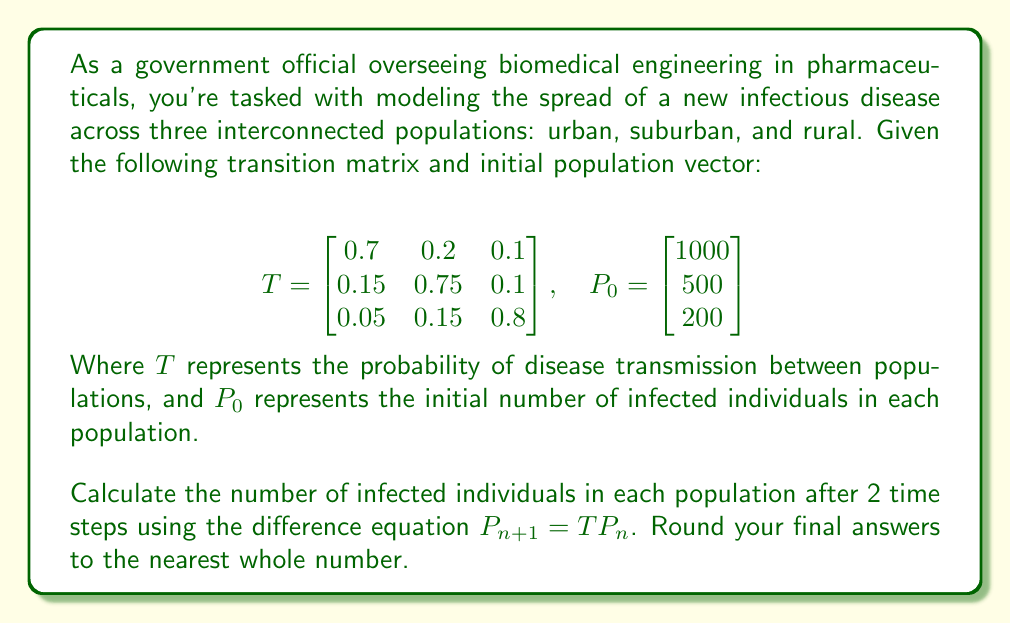Show me your answer to this math problem. To solve this problem, we'll use matrix multiplication and apply the difference equation twice.

Step 1: Calculate $P_1$ (infected population after 1 time step)
$$P_1 = TP_0 = \begin{bmatrix}
0.7 & 0.2 & 0.1 \\
0.15 & 0.75 & 0.1 \\
0.05 & 0.15 & 0.8
\end{bmatrix} \times \begin{bmatrix}
1000 \\
500 \\
200
\end{bmatrix}$$

$$P_1 = \begin{bmatrix}
(0.7 \times 1000) + (0.2 \times 500) + (0.1 \times 200) \\
(0.15 \times 1000) + (0.75 \times 500) + (0.1 \times 200) \\
(0.05 \times 1000) + (0.15 \times 500) + (0.8 \times 200)
\end{bmatrix}$$

$$P_1 = \begin{bmatrix}
700 + 100 + 20 \\
150 + 375 + 20 \\
50 + 75 + 160
\end{bmatrix} = \begin{bmatrix}
820 \\
545 \\
285
\end{bmatrix}$$

Step 2: Calculate $P_2$ (infected population after 2 time steps)
$$P_2 = TP_1 = \begin{bmatrix}
0.7 & 0.2 & 0.1 \\
0.15 & 0.75 & 0.1 \\
0.05 & 0.15 & 0.8
\end{bmatrix} \times \begin{bmatrix}
820 \\
545 \\
285
\end{bmatrix}$$

$$P_2 = \begin{bmatrix}
(0.7 \times 820) + (0.2 \times 545) + (0.1 \times 285) \\
(0.15 \times 820) + (0.75 \times 545) + (0.1 \times 285) \\
(0.05 \times 820) + (0.15 \times 545) + (0.8 \times 285)
\end{bmatrix}$$

$$P_2 = \begin{bmatrix}
574 + 109 + 28.5 \\
123 + 408.75 + 28.5 \\
41 + 81.75 + 228
\end{bmatrix} = \begin{bmatrix}
711.5 \\
560.25 \\
350.75
\end{bmatrix}$$

Step 3: Round the final answers to the nearest whole number
$$P_2 \approx \begin{bmatrix}
712 \\
560 \\
351
\end{bmatrix}$$
Answer: $P_2 = [712, 560, 351]$ 